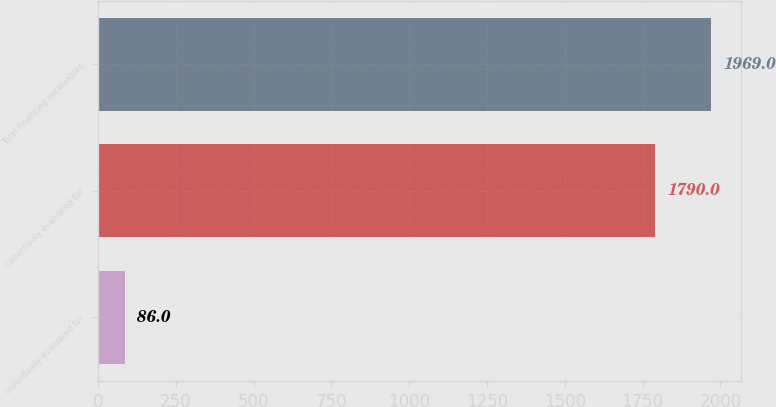Convert chart. <chart><loc_0><loc_0><loc_500><loc_500><bar_chart><fcel>Individually evaluated for<fcel>Collectively evaluated for<fcel>Total financing receivables<nl><fcel>86<fcel>1790<fcel>1969<nl></chart> 